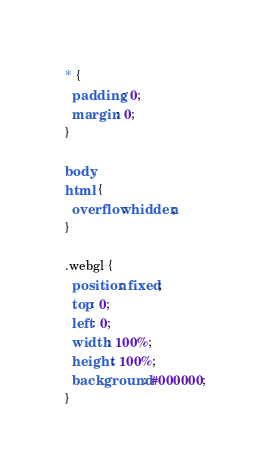<code> <loc_0><loc_0><loc_500><loc_500><_CSS_>* {
  padding: 0;
  margin: 0;
}

body,
html {
  overflow: hidden;
}

.webgl {
  position: fixed;
  top: 0;
  left: 0;
  width: 100%;
  height: 100%;
  background: #000000;
}
</code> 